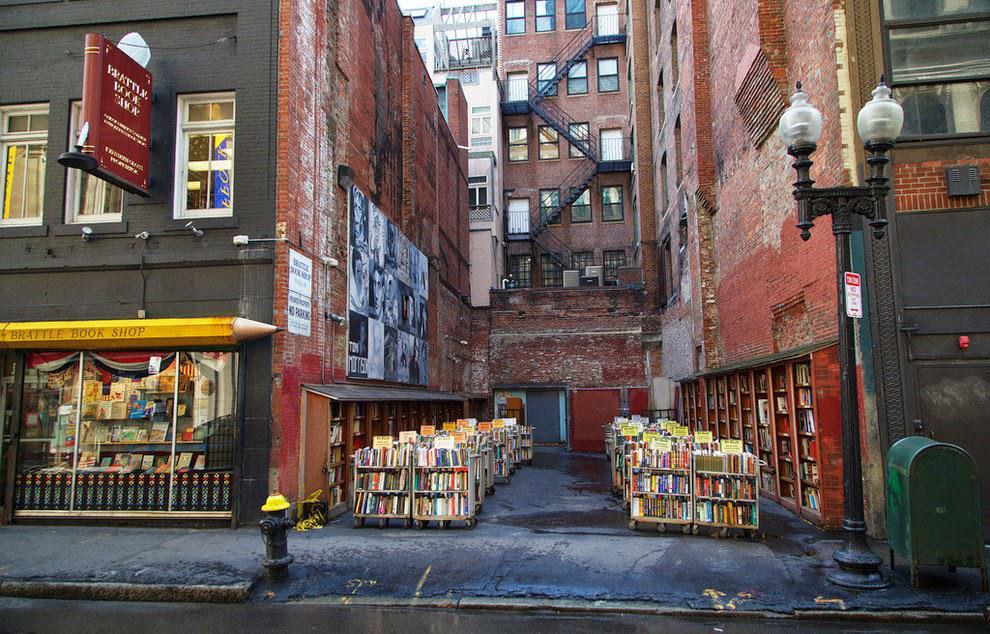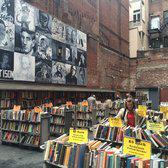The first image is the image on the left, the second image is the image on the right. Examine the images to the left and right. Is the description "A man in tan pants is standing up near a building in the image on the right." accurate? Answer yes or no. No. The first image is the image on the left, the second image is the image on the right. Evaluate the accuracy of this statement regarding the images: "An image shows a yellow sharpened pencil shape above shop windows and below a projecting reddish sign.". Is it true? Answer yes or no. Yes. 